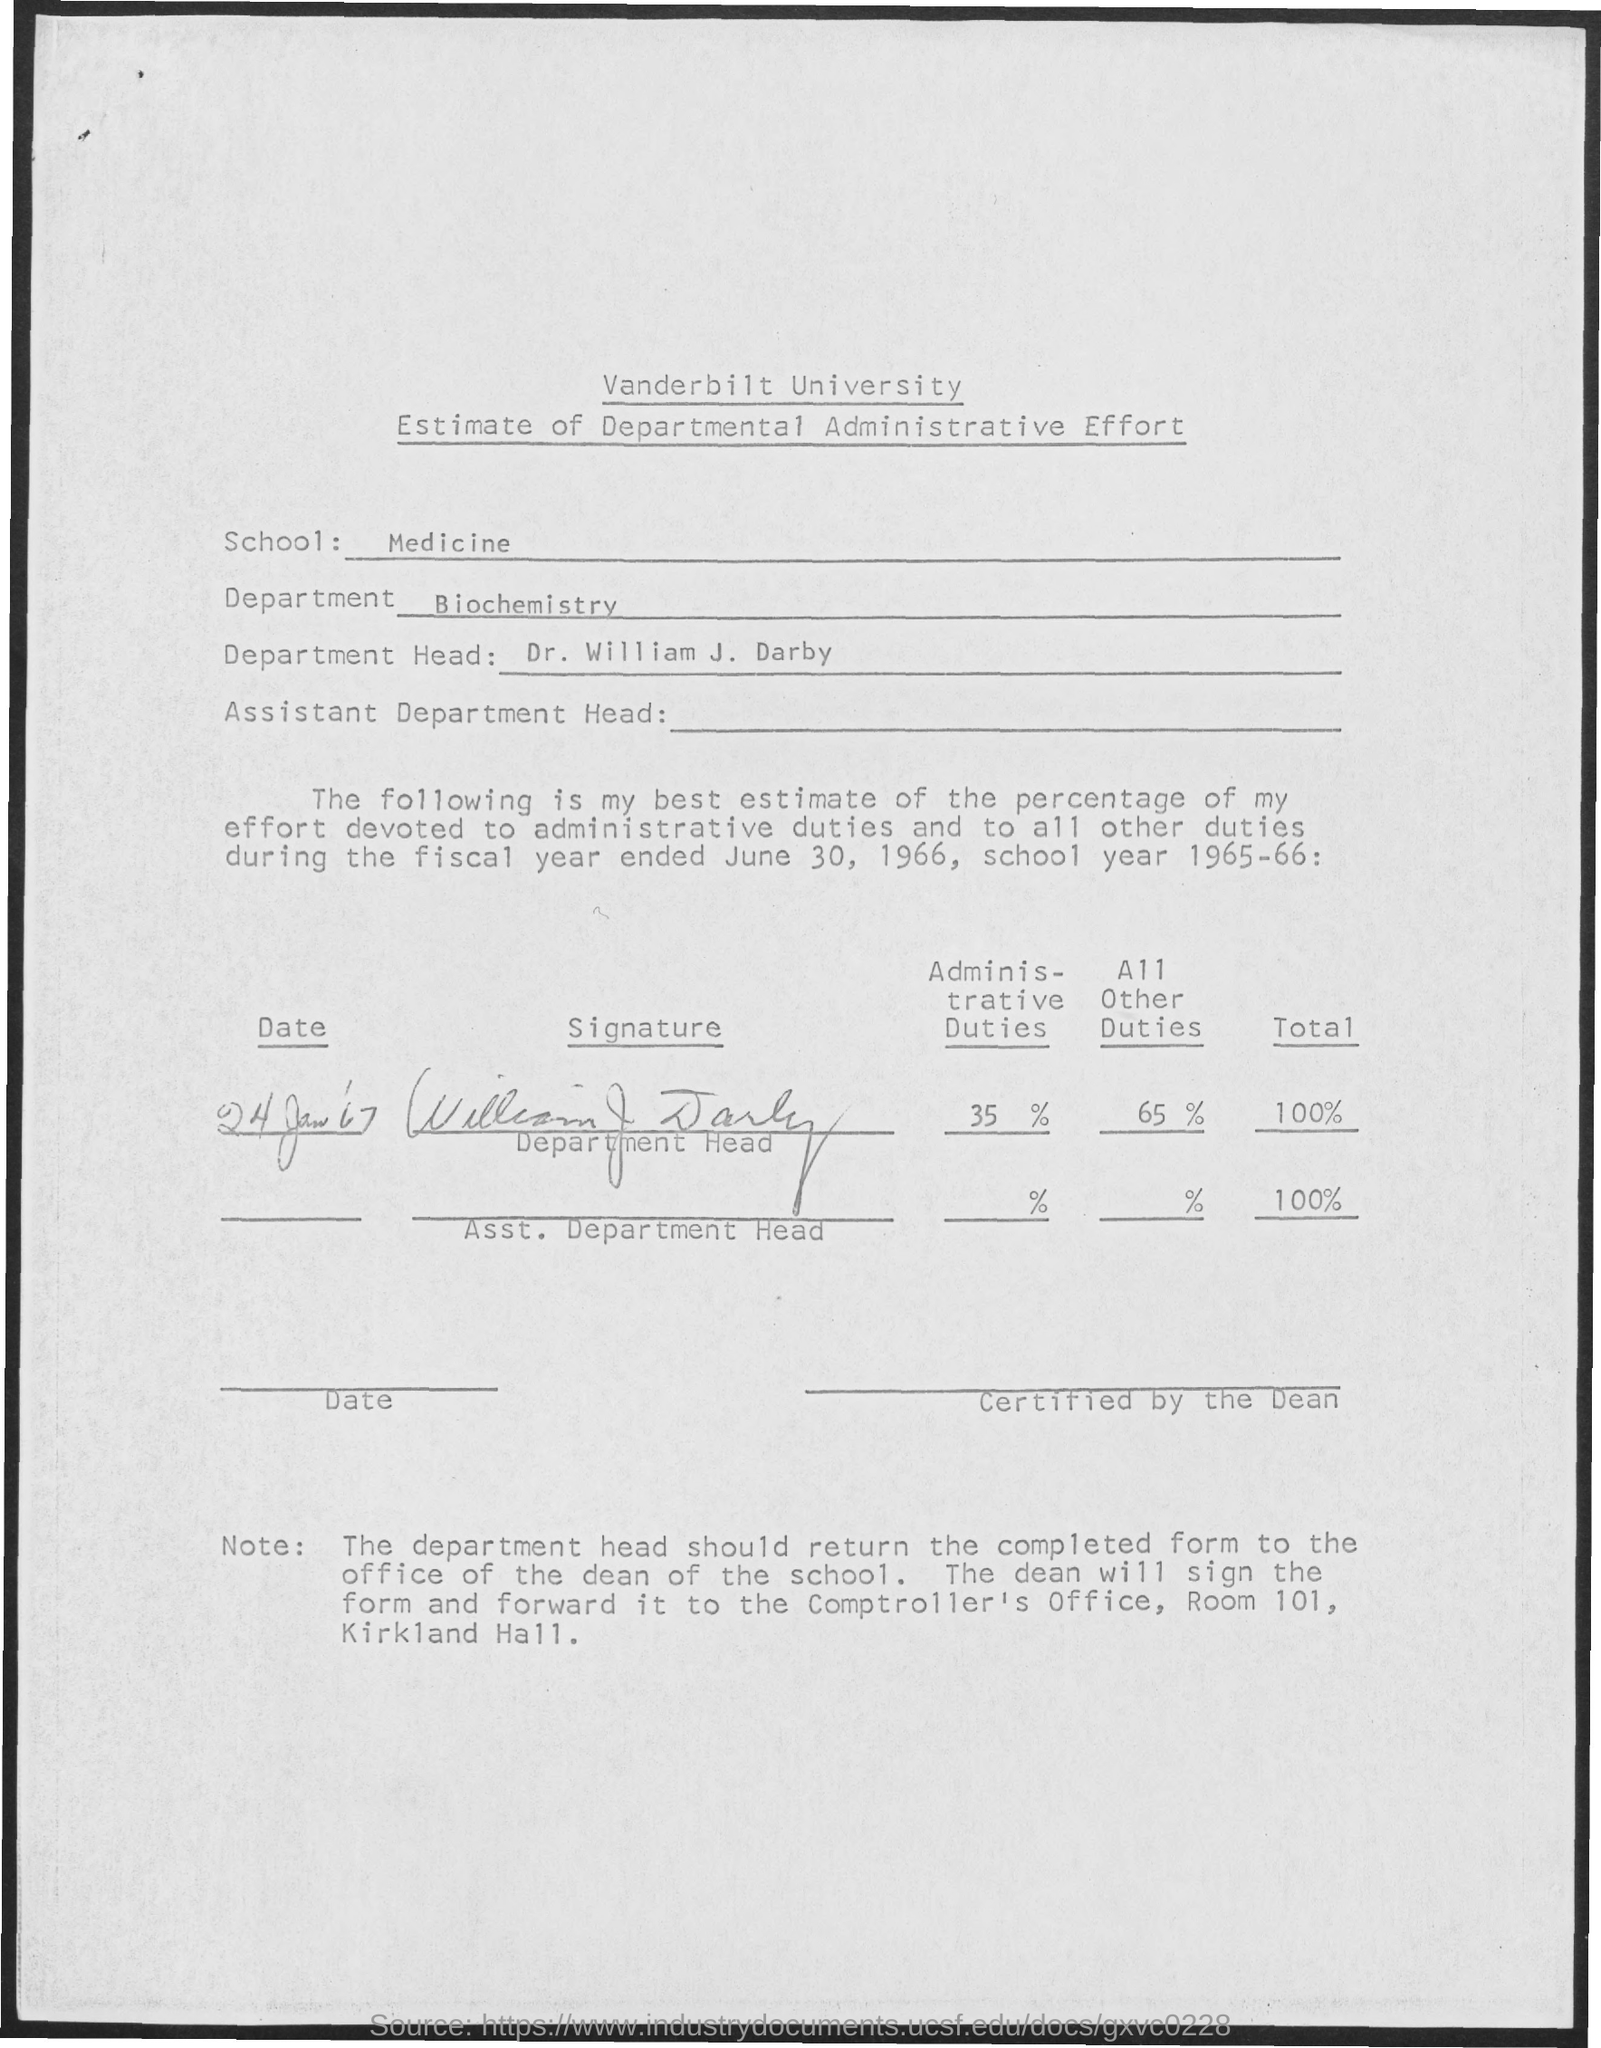Who is the head of the University Department?
Offer a very short reply. Dr. William J. Darby. What is the name of the Department?
Provide a short and direct response. Biochemistry. 